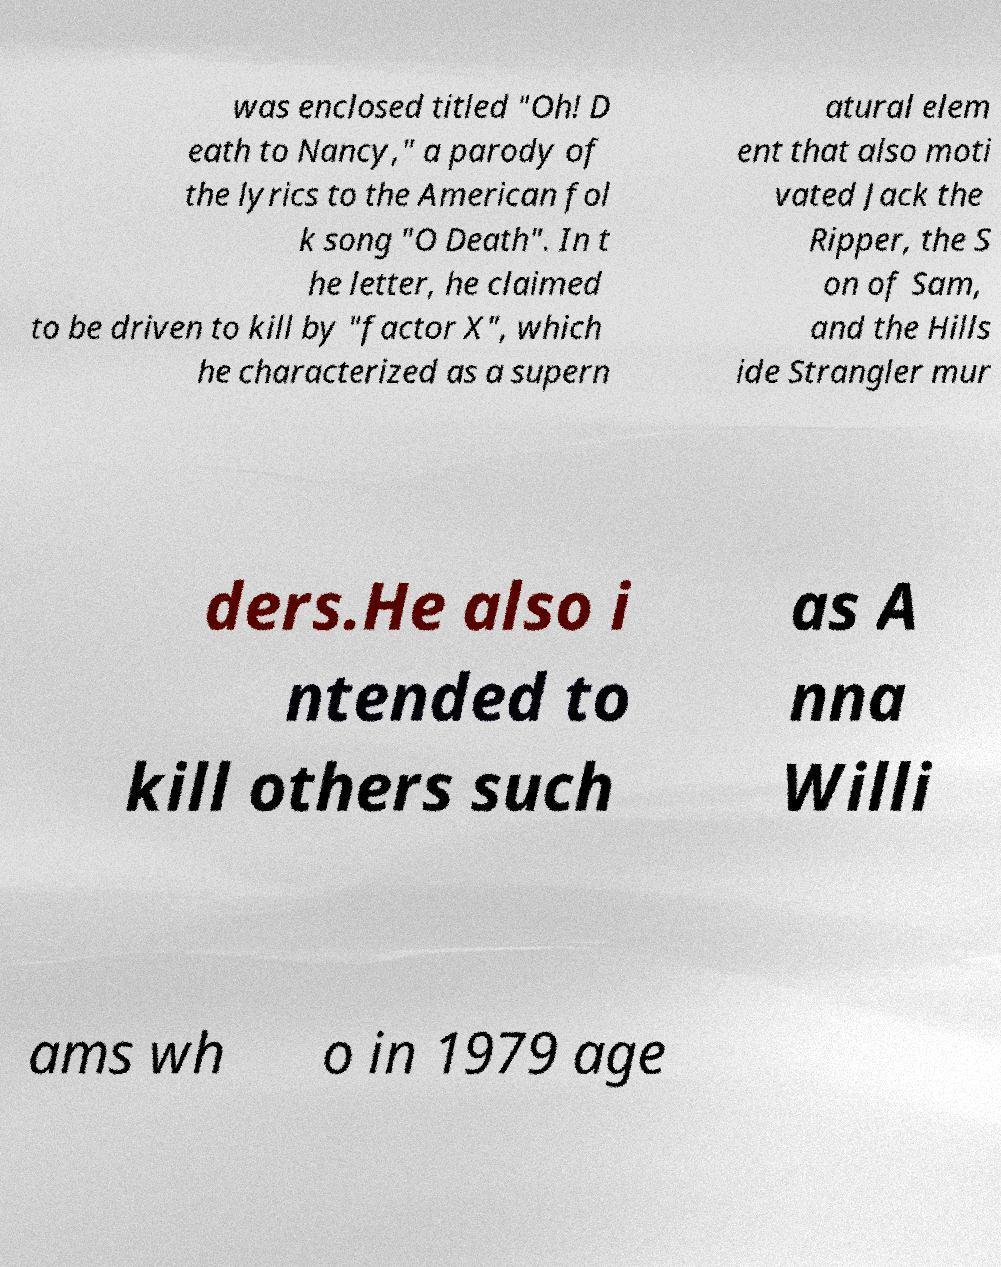Can you accurately transcribe the text from the provided image for me? was enclosed titled "Oh! D eath to Nancy," a parody of the lyrics to the American fol k song "O Death". In t he letter, he claimed to be driven to kill by "factor X", which he characterized as a supern atural elem ent that also moti vated Jack the Ripper, the S on of Sam, and the Hills ide Strangler mur ders.He also i ntended to kill others such as A nna Willi ams wh o in 1979 age 